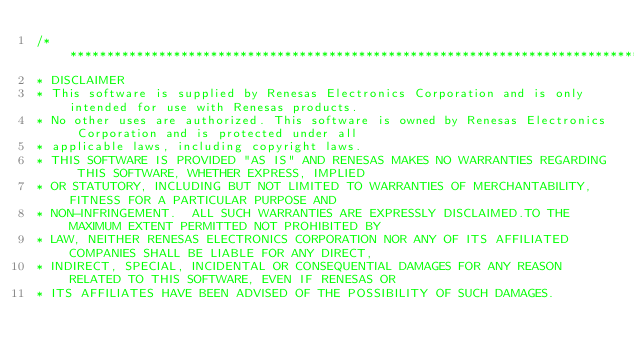Convert code to text. <code><loc_0><loc_0><loc_500><loc_500><_C_>/***********************************************************************************************************************
* DISCLAIMER
* This software is supplied by Renesas Electronics Corporation and is only intended for use with Renesas products.
* No other uses are authorized. This software is owned by Renesas Electronics Corporation and is protected under all
* applicable laws, including copyright laws. 
* THIS SOFTWARE IS PROVIDED "AS IS" AND RENESAS MAKES NO WARRANTIES REGARDING THIS SOFTWARE, WHETHER EXPRESS, IMPLIED
* OR STATUTORY, INCLUDING BUT NOT LIMITED TO WARRANTIES OF MERCHANTABILITY, FITNESS FOR A PARTICULAR PURPOSE AND
* NON-INFRINGEMENT.  ALL SUCH WARRANTIES ARE EXPRESSLY DISCLAIMED.TO THE MAXIMUM EXTENT PERMITTED NOT PROHIBITED BY
* LAW, NEITHER RENESAS ELECTRONICS CORPORATION NOR ANY OF ITS AFFILIATED COMPANIES SHALL BE LIABLE FOR ANY DIRECT,
* INDIRECT, SPECIAL, INCIDENTAL OR CONSEQUENTIAL DAMAGES FOR ANY REASON RELATED TO THIS SOFTWARE, EVEN IF RENESAS OR
* ITS AFFILIATES HAVE BEEN ADVISED OF THE POSSIBILITY OF SUCH DAMAGES.</code> 